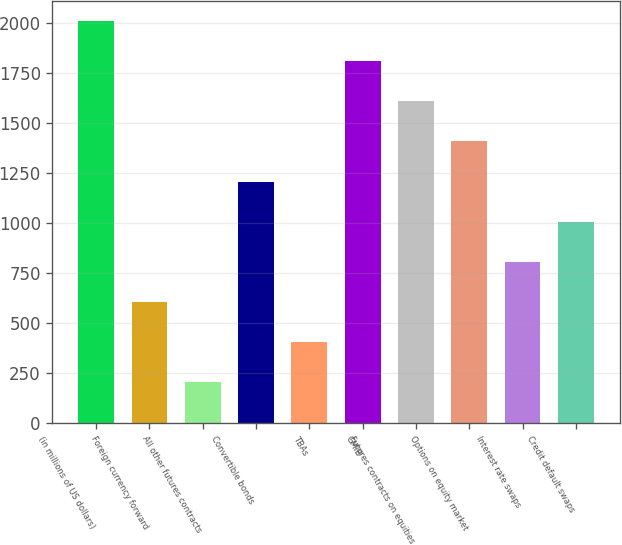Convert chart to OTSL. <chart><loc_0><loc_0><loc_500><loc_500><bar_chart><fcel>(in millions of US dollars)<fcel>Foreign currency forward<fcel>All other futures contracts<fcel>Convertible bonds<fcel>TBAs<fcel>GMIB<fcel>Futures contracts on equities<fcel>Options on equity market<fcel>Interest rate swaps<fcel>Credit default swaps<nl><fcel>2009<fcel>605.5<fcel>204.5<fcel>1207<fcel>405<fcel>1808.5<fcel>1608<fcel>1407.5<fcel>806<fcel>1006.5<nl></chart> 